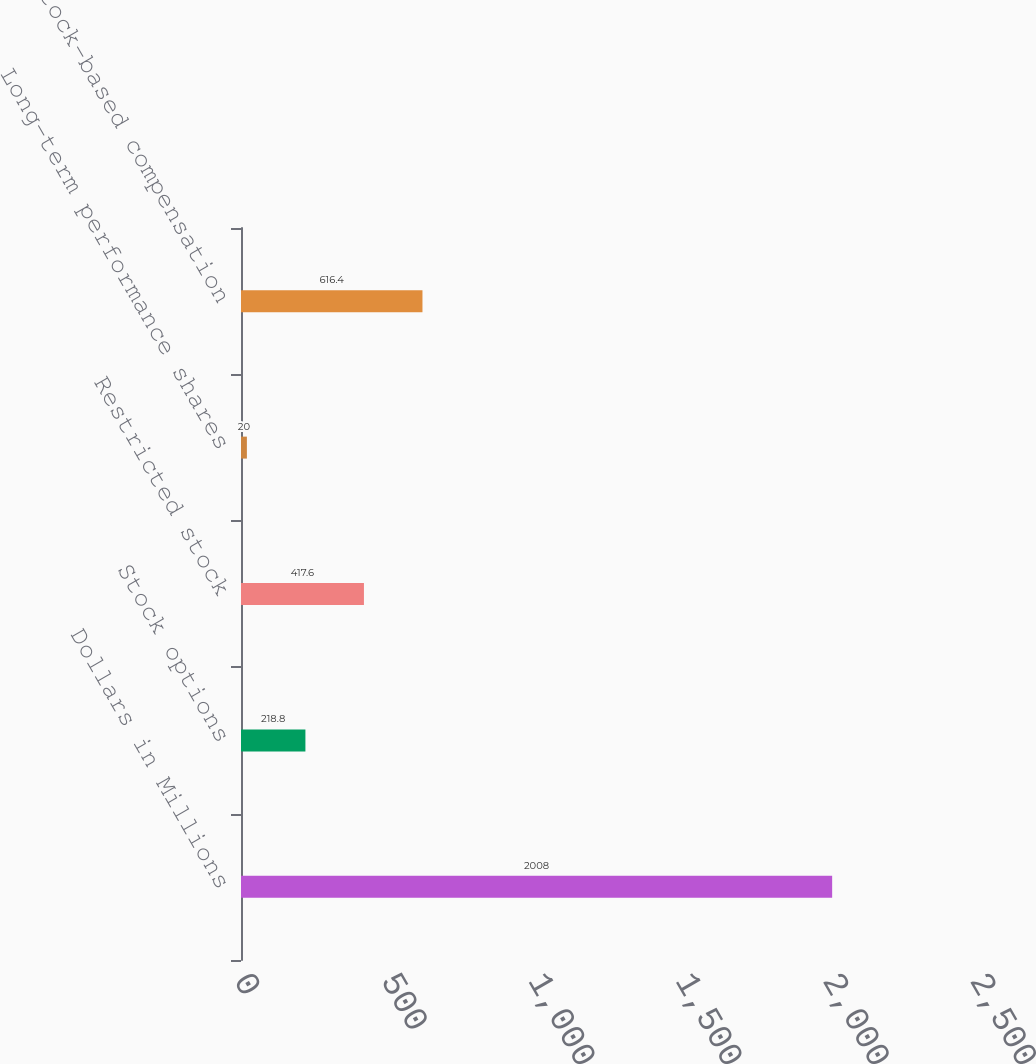Convert chart. <chart><loc_0><loc_0><loc_500><loc_500><bar_chart><fcel>Dollars in Millions<fcel>Stock options<fcel>Restricted stock<fcel>Long-term performance shares<fcel>Total stock-based compensation<nl><fcel>2008<fcel>218.8<fcel>417.6<fcel>20<fcel>616.4<nl></chart> 